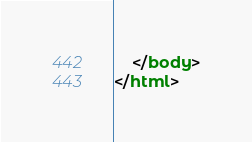<code> <loc_0><loc_0><loc_500><loc_500><_HTML_>    </body>
</html>

</code> 